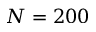Convert formula to latex. <formula><loc_0><loc_0><loc_500><loc_500>N = 2 0 0</formula> 